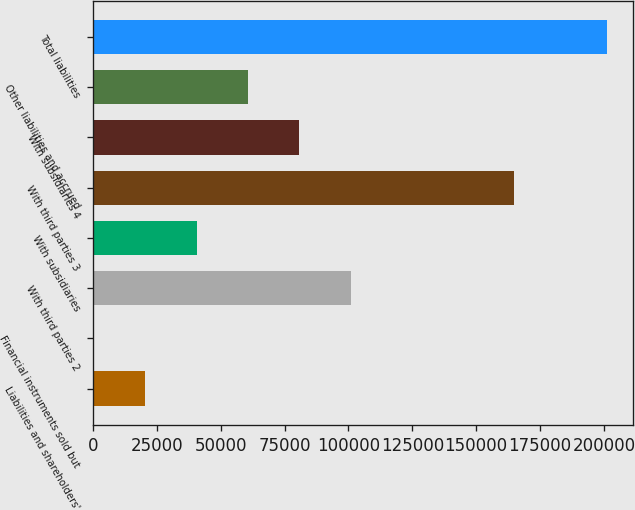Convert chart. <chart><loc_0><loc_0><loc_500><loc_500><bar_chart><fcel>Liabilities and shareholders'<fcel>Financial instruments sold but<fcel>With third parties 2<fcel>With subsidiaries<fcel>With third parties 3<fcel>With subsidiaries 4<fcel>Other liabilities and accrued<fcel>Total liabilities<nl><fcel>20531.5<fcel>443<fcel>100886<fcel>40620<fcel>164718<fcel>80797<fcel>60708.5<fcel>201328<nl></chart> 